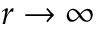<formula> <loc_0><loc_0><loc_500><loc_500>r \to \infty</formula> 